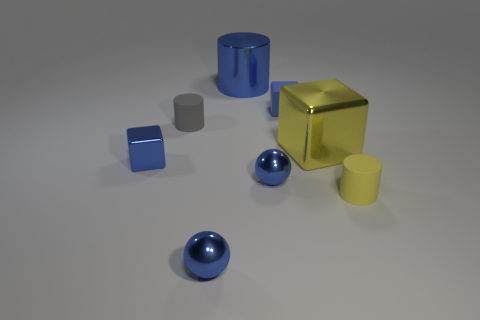How many tiny rubber things are the same color as the small rubber cube?
Provide a succinct answer. 0. Is the material of the tiny cylinder that is left of the blue matte cube the same as the large yellow thing?
Your response must be concise. No. What number of tiny yellow things have the same material as the small gray cylinder?
Your answer should be very brief. 1. Are there more small yellow things that are behind the small yellow thing than small blue rubber cubes?
Make the answer very short. No. There is a cylinder that is the same color as the large metallic block; what is its size?
Provide a short and direct response. Small. Are there any big yellow rubber things that have the same shape as the gray matte thing?
Your response must be concise. No. What number of things are blue cylinders or small rubber things?
Provide a short and direct response. 4. There is a blue metal object in front of the rubber object that is on the right side of the big metal cube; how many cylinders are in front of it?
Offer a very short reply. 0. What is the material of the other tiny object that is the same shape as the small blue rubber object?
Offer a very short reply. Metal. There is a tiny blue object that is behind the yellow rubber cylinder and on the left side of the blue shiny cylinder; what is its material?
Provide a succinct answer. Metal. 